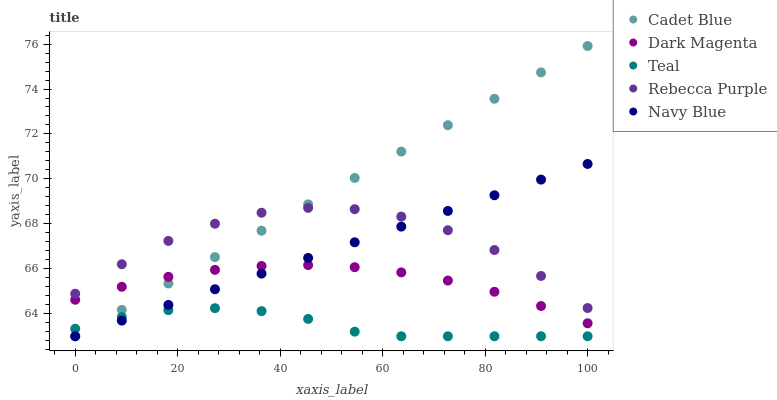Does Teal have the minimum area under the curve?
Answer yes or no. Yes. Does Cadet Blue have the maximum area under the curve?
Answer yes or no. Yes. Does Dark Magenta have the minimum area under the curve?
Answer yes or no. No. Does Dark Magenta have the maximum area under the curve?
Answer yes or no. No. Is Navy Blue the smoothest?
Answer yes or no. Yes. Is Rebecca Purple the roughest?
Answer yes or no. Yes. Is Cadet Blue the smoothest?
Answer yes or no. No. Is Cadet Blue the roughest?
Answer yes or no. No. Does Navy Blue have the lowest value?
Answer yes or no. Yes. Does Dark Magenta have the lowest value?
Answer yes or no. No. Does Cadet Blue have the highest value?
Answer yes or no. Yes. Does Dark Magenta have the highest value?
Answer yes or no. No. Is Teal less than Dark Magenta?
Answer yes or no. Yes. Is Rebecca Purple greater than Teal?
Answer yes or no. Yes. Does Cadet Blue intersect Dark Magenta?
Answer yes or no. Yes. Is Cadet Blue less than Dark Magenta?
Answer yes or no. No. Is Cadet Blue greater than Dark Magenta?
Answer yes or no. No. Does Teal intersect Dark Magenta?
Answer yes or no. No. 